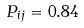<formula> <loc_0><loc_0><loc_500><loc_500>P _ { i j } = 0 . 8 4</formula> 